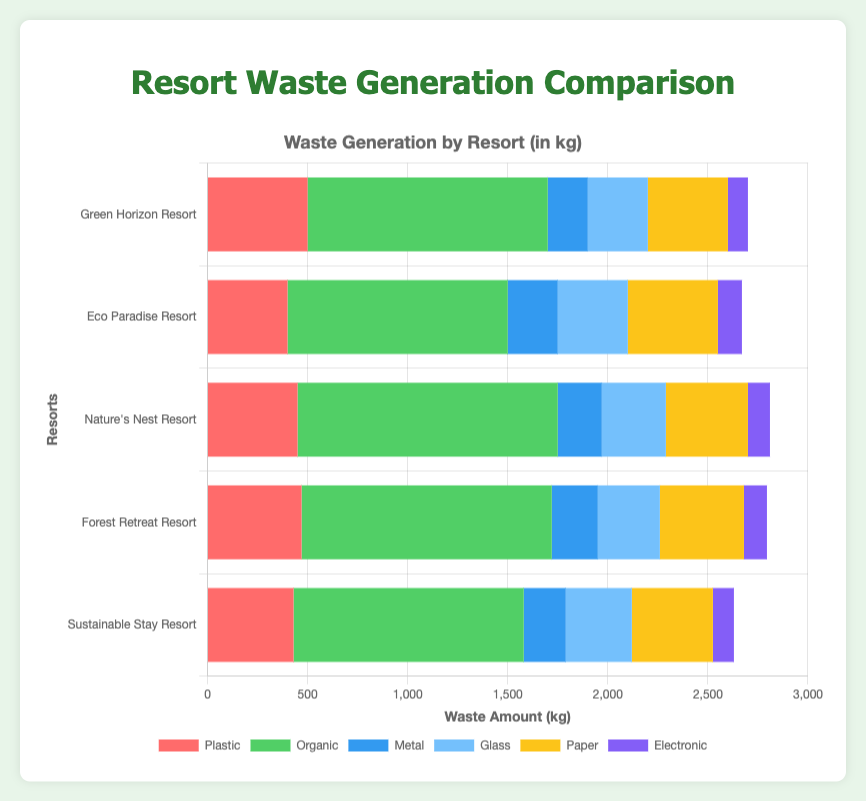What is the total amount of organic waste generated by all resorts combined? To find the total amount of organic waste, sum the organic waste reported by each resort: 1200 (Green Horizon) + 1100 (Eco Paradise) + 1300 (Nature's Nest) + 1250 (Forest Retreat) + 1150 (Sustainable Stay) = 6000 kg
Answer: 6000 kg Which resort generates the least amount of electronic waste? Compare the electronic waste values for all resorts: Green Horizon (100 kg), Eco Paradise (120 kg), Nature's Nest (110 kg), Forest Retreat (115 kg), and Sustainable Stay (105 kg). Green Horizon Resort generates the least amount of electronic waste with 100 kg.
Answer: Green Horizon Resort Does any resort generate more than 500 kg of plastic waste? Check the plastic waste values for all resorts: Green Horizon (500 kg), Eco Paradise (400 kg), Nature's Nest (450 kg), Forest Retreat (470 kg), Sustainable Stay (430 kg). None of the resorts generate more than 500 kg of plastic waste.
Answer: No Which resort has the highest amount of waste for a single type? Evaluate the highest value for each waste type across all resorts. The highest value observed is "organic waste" from Nature's Nest Resort with 1300 kg.
Answer: Nature's Nest Resort What is the average glass waste generated per resort? To find the average glass waste, sum the glass waste values: 300 (Green Horizon) + 350 (Eco Paradise) + 320 (Nature's Nest) + 310 (Forest Retreat) + 330 (Sustainable Stay) and divide by the number of resorts (5): (300 + 350 + 320 + 310 + 330)/5 = 1610/5 = 322 kg
Answer: 322 kg Which type of waste is the most commonly generated in terms of absolute values across all resorts? Sum the values for each waste type across all resorts and compare: Plastic (500+400+450+470+430), Organic (1200+1100+1300+1250+1150), Metal (200+250+220+230+210), Glass (300+350+320+310+330), Paper (400+450+410+420+405), Electronic (100+120+110+115+105). The type with the highest total is organic waste with a sum of 6000 kg.
Answer: Organic waste Which resort consistently produces the second-highest amount of waste in each category? Compare the second highest amount across all waste categories. Identify that Eco Paradise Resort consistently produces the second-highest amount across multiple categories: Organic (1100 kg), Metal (250 kg), and Paper (450 kg).
Answer: Eco Paradise Resort How much more paper waste does Green Horizon Resort generate compared to Nature's Nest Resort? Subtract the paper waste of Nature's Nest from Green Horizon: 400 (Green Horizon) - 410 (Nature's Nest) = -10 kg. Green Horizon generates 10 kg less paper waste compared to Nature's Nest.
Answer: -10 kg 